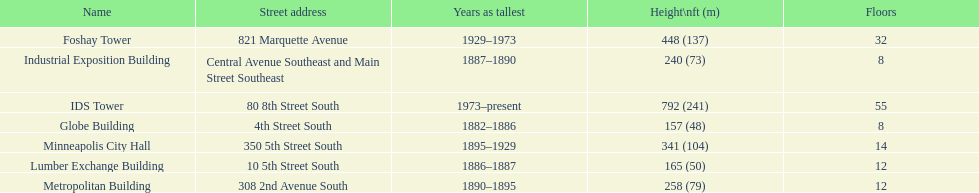Is the metropolitan building or the lumber exchange building taller? Metropolitan Building. 